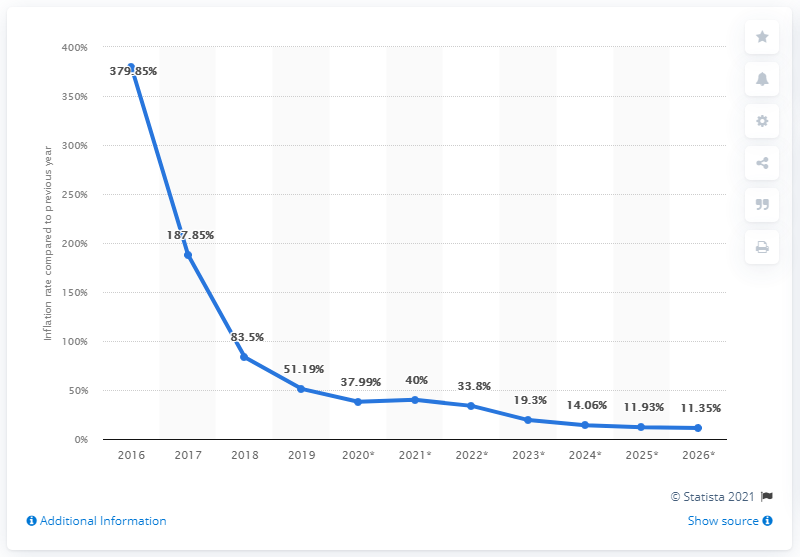Identify some key points in this picture. In 2016, the average inflation rate in South Sudan was X. 